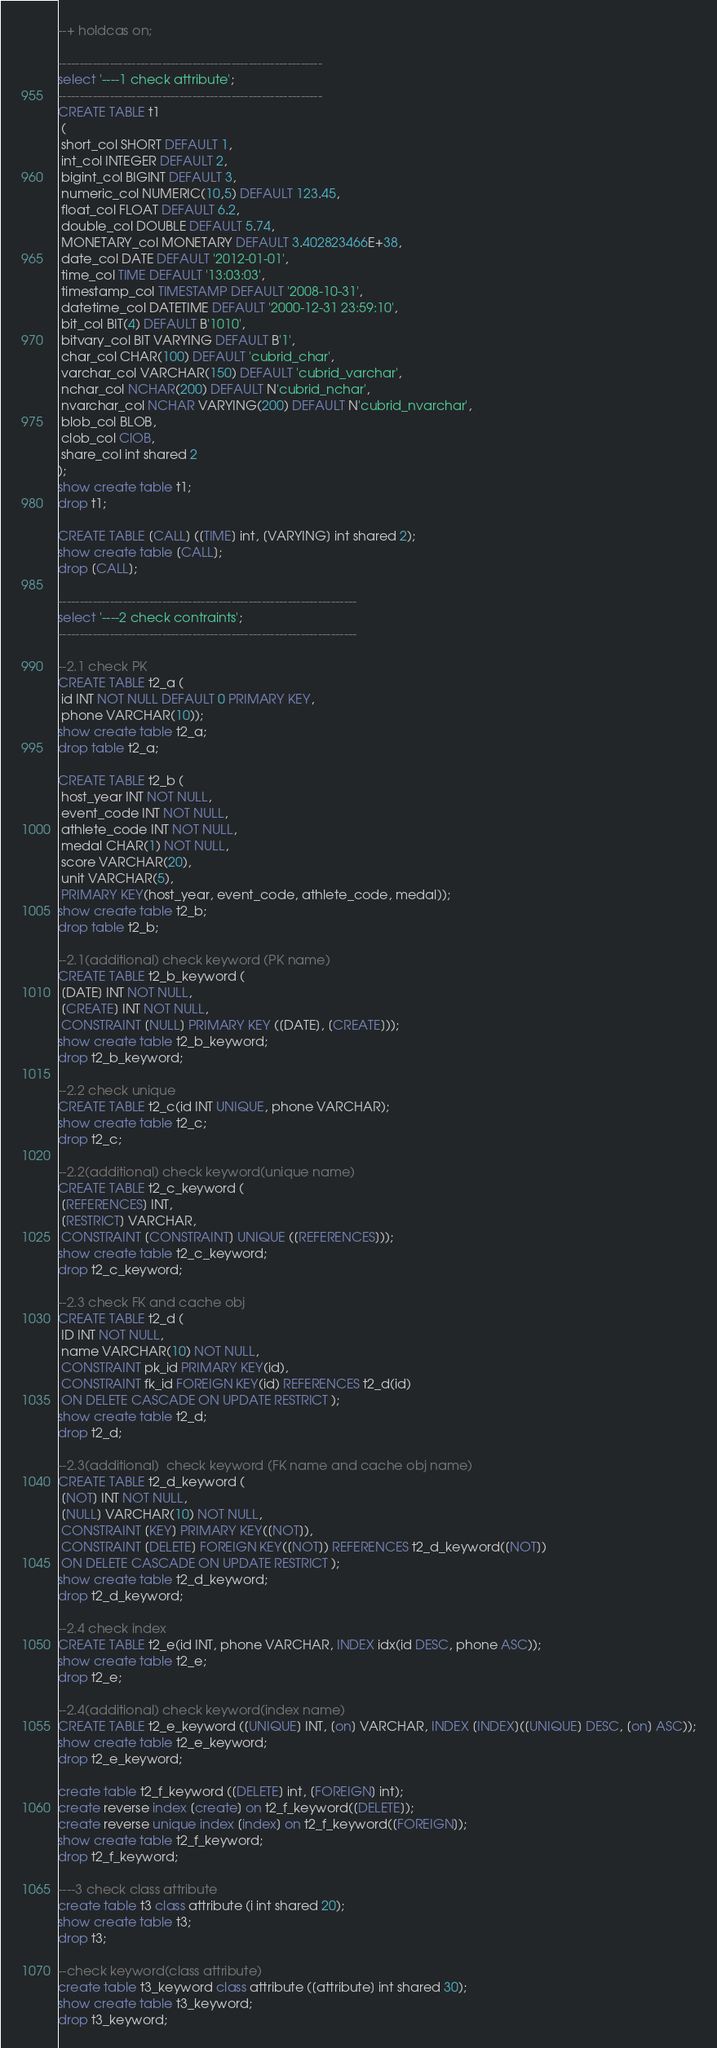<code> <loc_0><loc_0><loc_500><loc_500><_SQL_>--+ holdcas on;

-------------------------------------------------------------
select '----1 check attribute';
-------------------------------------------------------------
CREATE TABLE t1
 (
 short_col SHORT DEFAULT 1,
 int_col INTEGER DEFAULT 2,
 bigint_col BIGINT DEFAULT 3, 
 numeric_col NUMERIC(10,5) DEFAULT 123.45, 
 float_col FLOAT DEFAULT 6.2,
 double_col DOUBLE DEFAULT 5.74,
 MONETARY_col MONETARY DEFAULT 3.402823466E+38,
 date_col DATE DEFAULT '2012-01-01',
 time_col TIME DEFAULT '13:03:03',
 timestamp_col TIMESTAMP DEFAULT '2008-10-31',
 datetime_col DATETIME DEFAULT '2000-12-31 23:59:10',
 bit_col BIT(4) DEFAULT B'1010',
 bitvary_col BIT VARYING DEFAULT B'1',
 char_col CHAR(100) DEFAULT 'cubrid_char',
 varchar_col VARCHAR(150) DEFAULT 'cubrid_varchar',
 nchar_col NCHAR(200) DEFAULT N'cubrid_nchar',
 nvarchar_col NCHAR VARYING(200) DEFAULT N'cubrid_nvarchar',
 blob_col BLOB,
 clob_col ClOB,
 share_col int shared 2
);
show create table t1;
drop t1;

CREATE TABLE [CALL] ([TIME] int, [VARYING] int shared 2);
show create table [CALL];
drop [CALL];

---------------------------------------------------------------------
select '----2 check contraints';
---------------------------------------------------------------------

--2.1 check PK
CREATE TABLE t2_a (
 id INT NOT NULL DEFAULT 0 PRIMARY KEY,
 phone VARCHAR(10));
show create table t2_a;
drop table t2_a;

CREATE TABLE t2_b (
 host_year INT NOT NULL,
 event_code INT NOT NULL,
 athlete_code INT NOT NULL,
 medal CHAR(1) NOT NULL,
 score VARCHAR(20),
 unit VARCHAR(5),
 PRIMARY KEY(host_year, event_code, athlete_code, medal));
show create table t2_b;
drop table t2_b;

--2.1(additional) check keyword (PK name)
CREATE TABLE t2_b_keyword (
 [DATE] INT NOT NULL,
 [CREATE] INT NOT NULL,
 CONSTRAINT [NULL] PRIMARY KEY ([DATE], [CREATE]));
show create table t2_b_keyword;
drop t2_b_keyword;

--2.2 check unique
CREATE TABLE t2_c(id INT UNIQUE, phone VARCHAR);
show create table t2_c;
drop t2_c;

--2.2(additional) check keyword(unique name)
CREATE TABLE t2_c_keyword (
 [REFERENCES] INT, 
 [RESTRICT] VARCHAR,
 CONSTRAINT [CONSTRAINT] UNIQUE ([REFERENCES]));
show create table t2_c_keyword;
drop t2_c_keyword;

--2.3 check FK and cache obj
CREATE TABLE t2_d (
 ID INT NOT NULL,
 name VARCHAR(10) NOT NULL,
 CONSTRAINT pk_id PRIMARY KEY(id),
 CONSTRAINT fk_id FOREIGN KEY(id) REFERENCES t2_d(id)
 ON DELETE CASCADE ON UPDATE RESTRICT );
show create table t2_d;
drop t2_d;

--2.3(additional)  check keyword (FK name and cache obj name)
CREATE TABLE t2_d_keyword (
 [NOT] INT NOT NULL,
 [NULL] VARCHAR(10) NOT NULL,
 CONSTRAINT [KEY] PRIMARY KEY([NOT]),
 CONSTRAINT [DELETE] FOREIGN KEY([NOT]) REFERENCES t2_d_keyword([NOT])
 ON DELETE CASCADE ON UPDATE RESTRICT );
show create table t2_d_keyword;
drop t2_d_keyword;

--2.4 check index
CREATE TABLE t2_e(id INT, phone VARCHAR, INDEX idx(id DESC, phone ASC));
show create table t2_e;
drop t2_e;

--2.4(additional) check keyword(index name)
CREATE TABLE t2_e_keyword ([UNIQUE] INT, [on] VARCHAR, INDEX [INDEX]([UNIQUE] DESC, [on] ASC));
show create table t2_e_keyword;
drop t2_e_keyword;

create table t2_f_keyword ([DELETE] int, [FOREIGN] int);
create reverse index [create] on t2_f_keyword([DELETE]);
create reverse unique index [index] on t2_f_keyword([FOREIGN]);
show create table t2_f_keyword;
drop t2_f_keyword;

----3 check class attribute
create table t3 class attribute (i int shared 20);
show create table t3;
drop t3;

--check keyword(class attribute)
create table t3_keyword class attribute ([attribute] int shared 30);
show create table t3_keyword;
drop t3_keyword;
</code> 